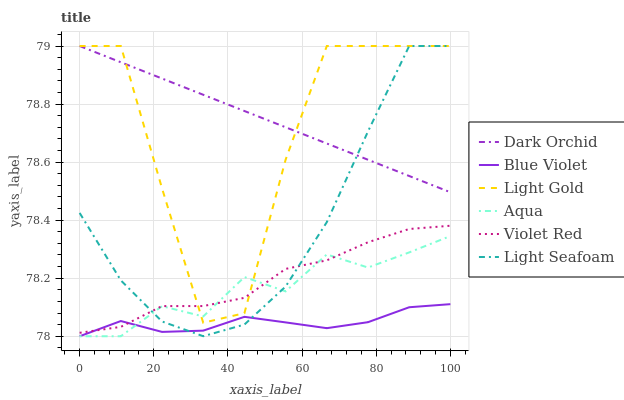Does Aqua have the minimum area under the curve?
Answer yes or no. No. Does Aqua have the maximum area under the curve?
Answer yes or no. No. Is Aqua the smoothest?
Answer yes or no. No. Is Aqua the roughest?
Answer yes or no. No. Does Dark Orchid have the lowest value?
Answer yes or no. No. Does Aqua have the highest value?
Answer yes or no. No. Is Blue Violet less than Dark Orchid?
Answer yes or no. Yes. Is Light Gold greater than Blue Violet?
Answer yes or no. Yes. Does Blue Violet intersect Dark Orchid?
Answer yes or no. No. 